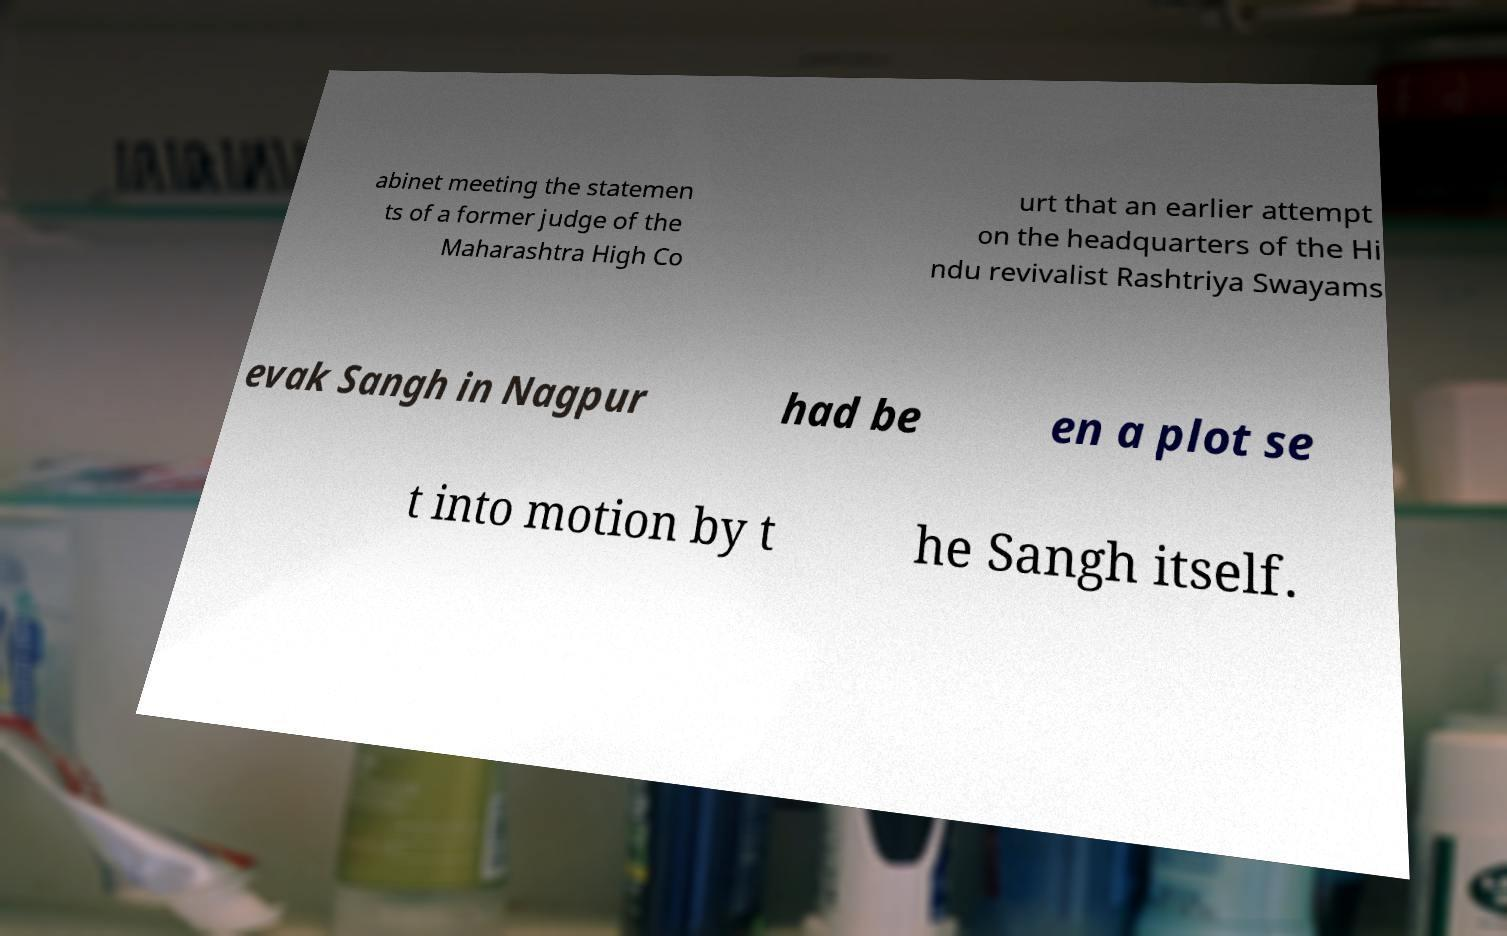Could you extract and type out the text from this image? abinet meeting the statemen ts of a former judge of the Maharashtra High Co urt that an earlier attempt on the headquarters of the Hi ndu revivalist Rashtriya Swayams evak Sangh in Nagpur had be en a plot se t into motion by t he Sangh itself. 